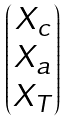<formula> <loc_0><loc_0><loc_500><loc_500>\begin{pmatrix} X _ { c } \\ X _ { a } \\ X _ { T } \end{pmatrix}</formula> 